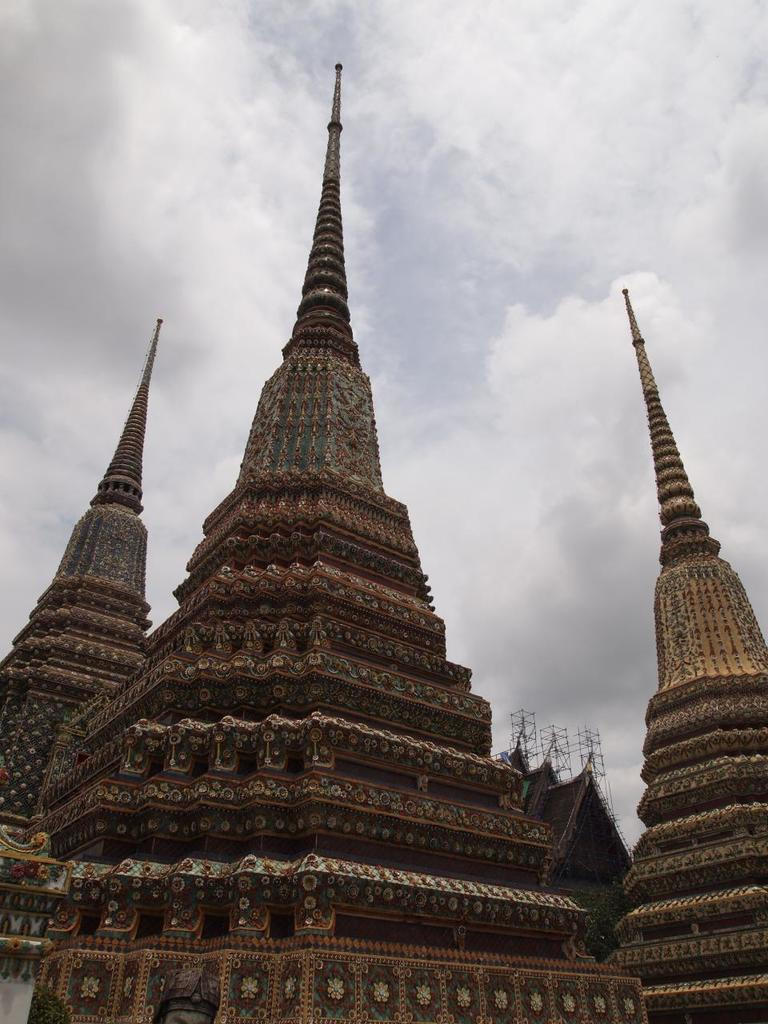What type of buildings can be seen in the image? There are temples in the image. Where is the birth of the first temple in the image? There is no information about the birth of the temples in the image, as it only shows their current state. 